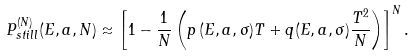Convert formula to latex. <formula><loc_0><loc_0><loc_500><loc_500>P _ { s t i l l } ^ { ( N ) } ( E , a , N ) \approx \left [ 1 - \frac { 1 } { N } \left ( p \, ( E , a , \sigma ) T + q ( E , a , \sigma ) \frac { T ^ { 2 } } { N } \right ) \right ] ^ { N } .</formula> 